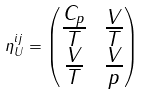Convert formula to latex. <formula><loc_0><loc_0><loc_500><loc_500>\eta ^ { i j } _ { U } = \begin{pmatrix} \frac { C _ { p } } { T } & \frac { V } { T } \\ \frac { V } { T } & \frac { V } { p } \end{pmatrix}</formula> 